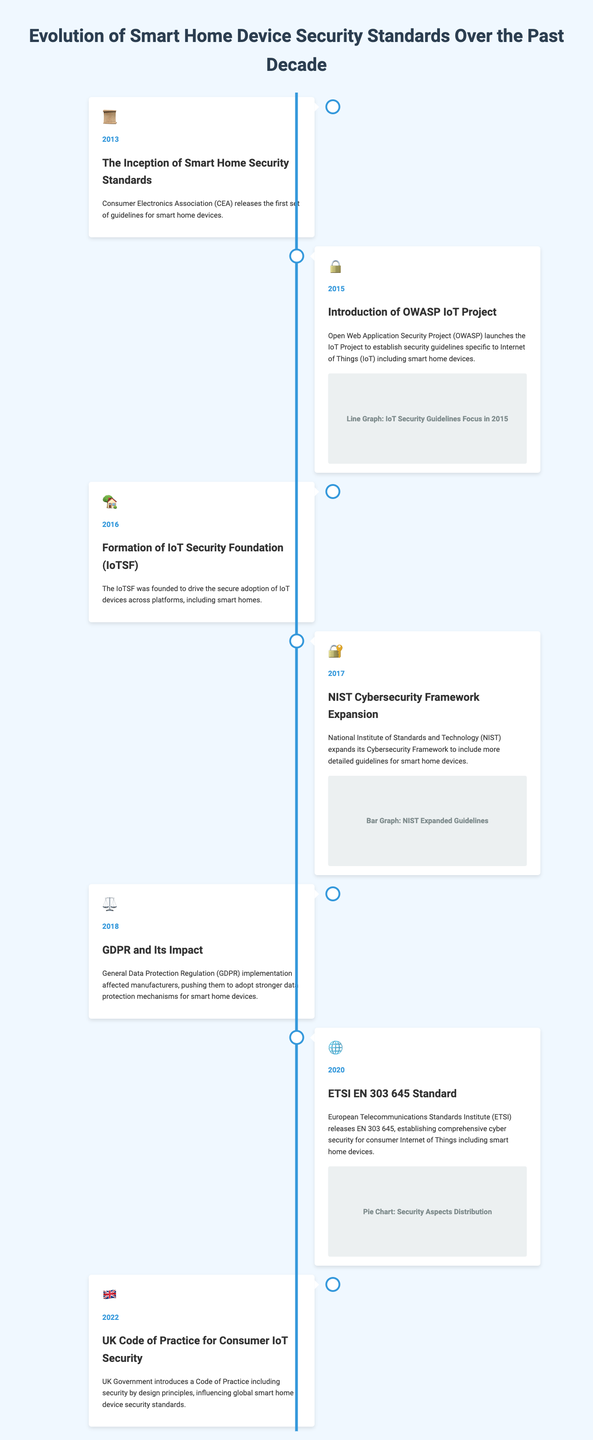What year did the Consumer Electronics Association release the first guidelines? The document states that the Consumer Electronics Association released the first set of guidelines for smart home devices in 2013.
Answer: 2013 What organization launched the IoT Project in 2015? According to the infographic, the Open Web Application Security Project launched the IoT Project to establish security guidelines in 2015.
Answer: Open Web Application Security Project What was founded in 2016 to drive secure adoption of IoT devices? The infographic indicates that the IoT Security Foundation was founded in 2016 to promote secure adoption of IoT devices.
Answer: IoT Security Foundation Which regulation impacted smart home device manufacturers in 2018? The document notes that the implementation of the General Data Protection Regulation in 2018 impacted manufacturers.
Answer: GDPR What standard did the European Telecommunications Standards Institute release in 2020? The infographic reveals that the ETSI released the EN 303 645 standard in 2020 for comprehensive cybersecurity for consumer IoT.
Answer: EN 303 645 What year did the UK introduce a Code of Practice for Consumer IoT Security? According to the document, the UK Government introduced a Code of Practice for Consumer IoT Security in 2022.
Answer: 2022 What significant change occurred in the cybersecurity guidelines in 2017? The document states that in 2017, the National Institute of Standards and Technology expanded its Cybersecurity Framework to include more detailed guidelines for smart home devices.
Answer: Expanded guidelines What type of graph is associated with the introduction of OWASP IoT Project? The infographic mentions that a line graph representing IoT Security Guidelines Focus is associated with the OWASP IoT Project in 2015.
Answer: Line Graph What aspect does the ETSI EN 303 645 standard cover? The document specifies that the ETSI EN 303 645 establishes comprehensive cybersecurity for consumer Internet of Things devices.
Answer: Cybersecurity 